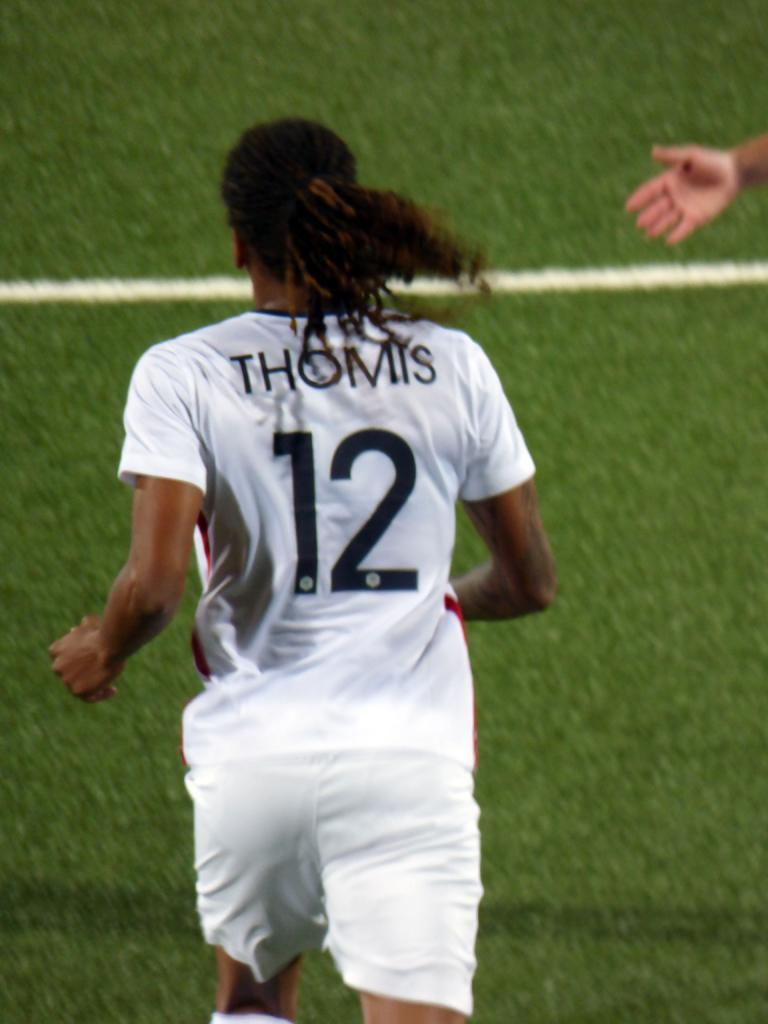Provide a one-sentence caption for the provided image. Soccer player number 12 on the field is Thomis. 